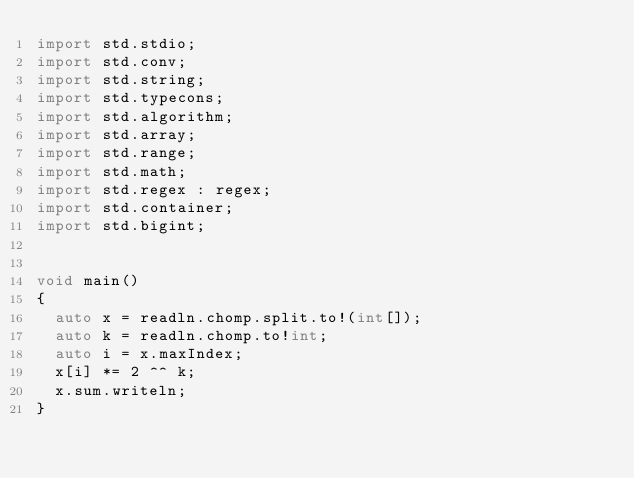<code> <loc_0><loc_0><loc_500><loc_500><_D_>import std.stdio;
import std.conv;
import std.string;
import std.typecons;
import std.algorithm;
import std.array;
import std.range;
import std.math;
import std.regex : regex;
import std.container;
import std.bigint;


void main()
{
  auto x = readln.chomp.split.to!(int[]);
  auto k = readln.chomp.to!int;
  auto i = x.maxIndex;
  x[i] *= 2 ^^ k;
  x.sum.writeln;
}
</code> 